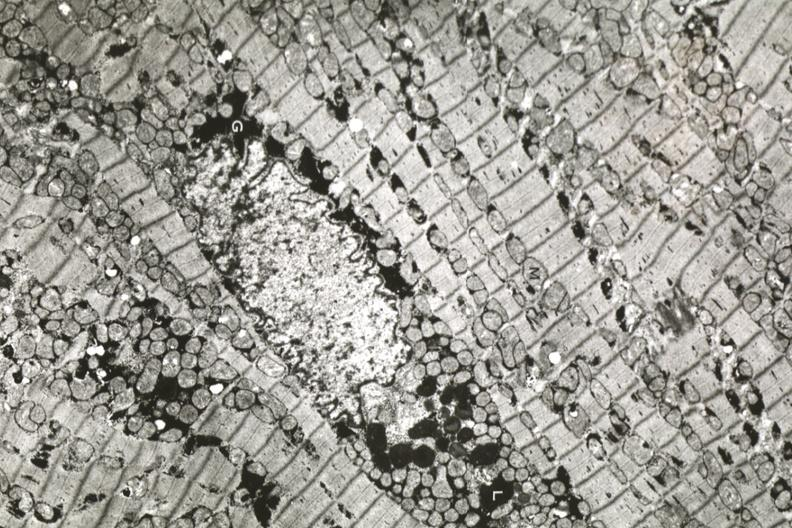s pus in test tube present?
Answer the question using a single word or phrase. No 